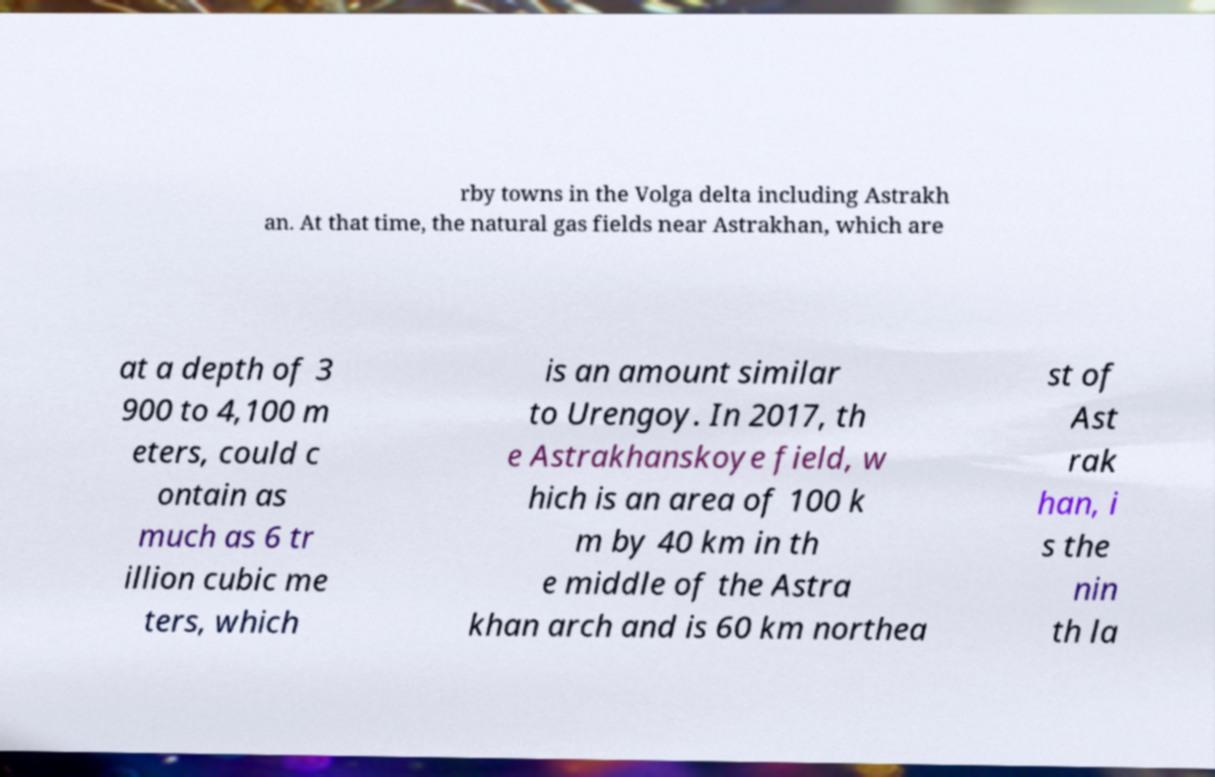Could you extract and type out the text from this image? rby towns in the Volga delta including Astrakh an. At that time, the natural gas fields near Astrakhan, which are at a depth of 3 900 to 4,100 m eters, could c ontain as much as 6 tr illion cubic me ters, which is an amount similar to Urengoy. In 2017, th e Astrakhanskoye field, w hich is an area of 100 k m by 40 km in th e middle of the Astra khan arch and is 60 km northea st of Ast rak han, i s the nin th la 